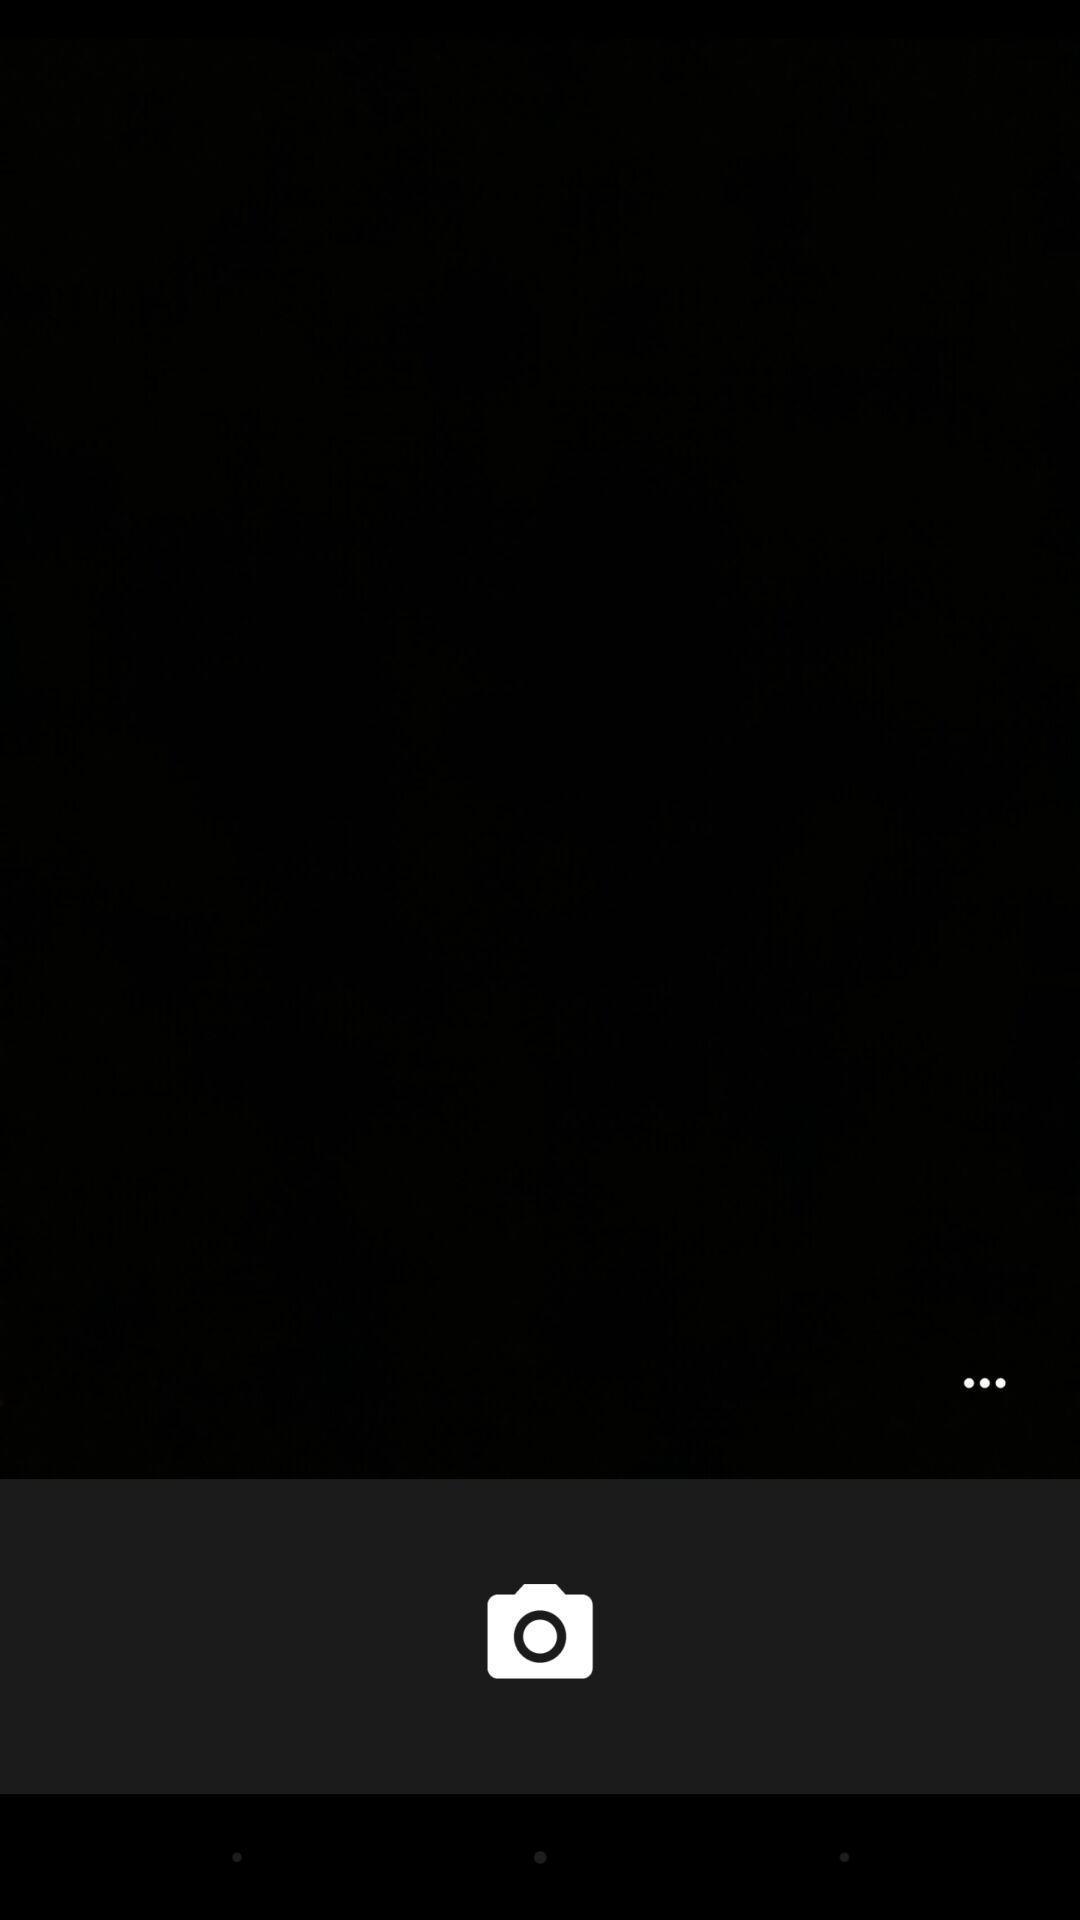Describe this image in words. Page displaying with camera application opened. 